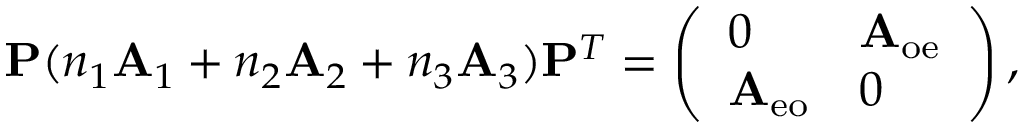<formula> <loc_0><loc_0><loc_500><loc_500>P ( n _ { 1 } A _ { 1 } + n _ { 2 } A _ { 2 } + n _ { 3 } A _ { 3 } ) P ^ { T } = \left ( \begin{array} { l l } { 0 } & { A _ { o e } } \\ { A _ { e o } } & { 0 } \end{array} \right ) ,</formula> 